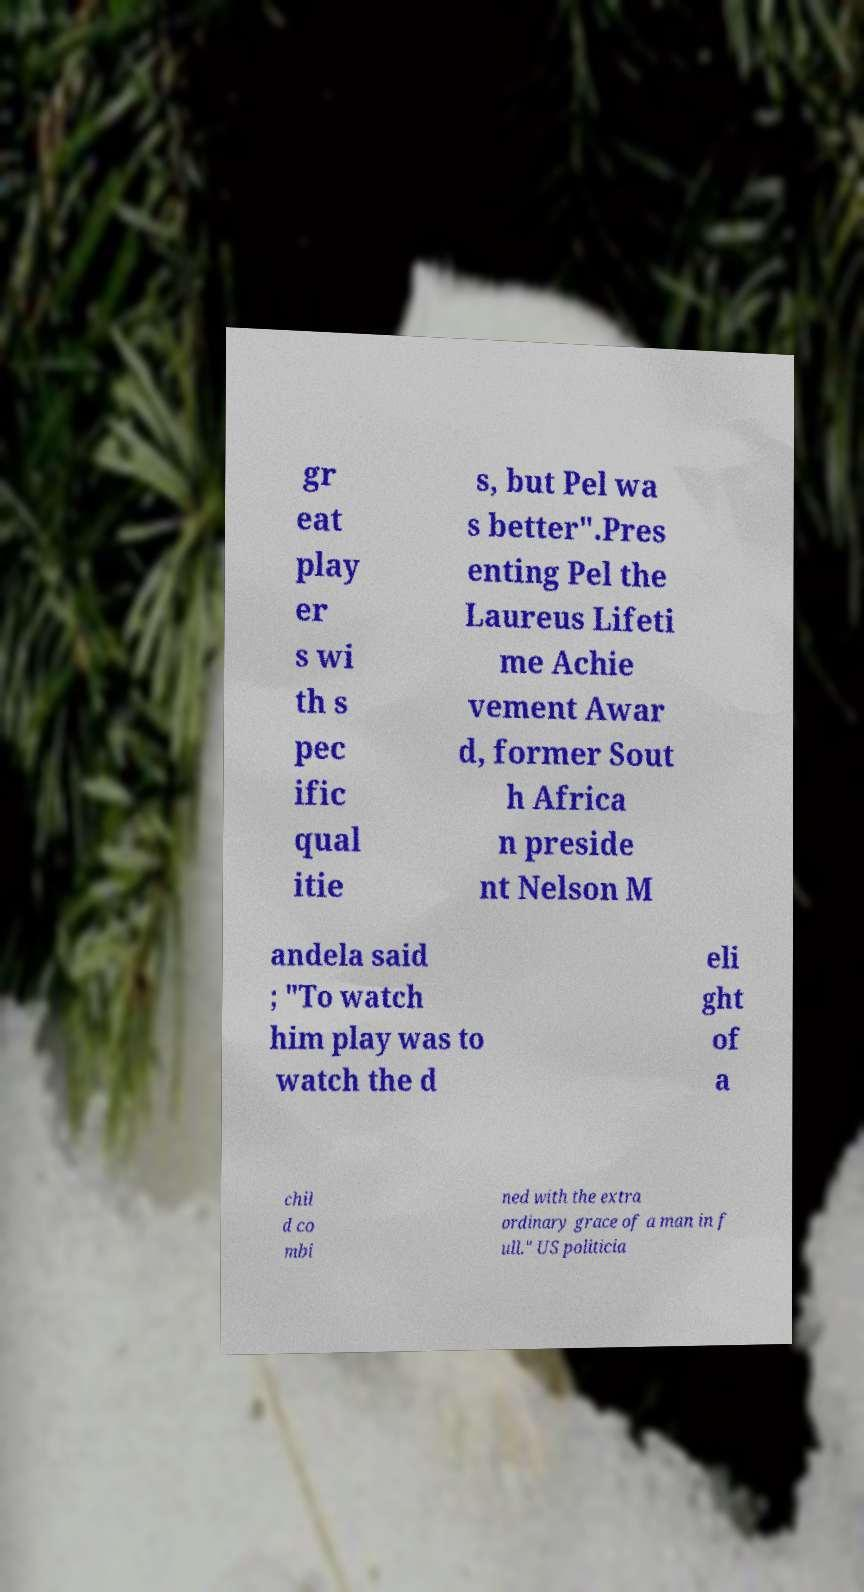Can you read and provide the text displayed in the image?This photo seems to have some interesting text. Can you extract and type it out for me? gr eat play er s wi th s pec ific qual itie s, but Pel wa s better".Pres enting Pel the Laureus Lifeti me Achie vement Awar d, former Sout h Africa n preside nt Nelson M andela said ; "To watch him play was to watch the d eli ght of a chil d co mbi ned with the extra ordinary grace of a man in f ull." US politicia 